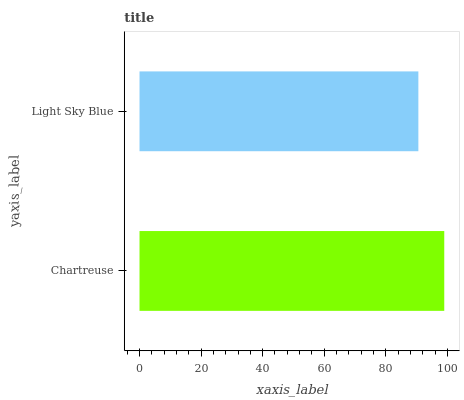Is Light Sky Blue the minimum?
Answer yes or no. Yes. Is Chartreuse the maximum?
Answer yes or no. Yes. Is Light Sky Blue the maximum?
Answer yes or no. No. Is Chartreuse greater than Light Sky Blue?
Answer yes or no. Yes. Is Light Sky Blue less than Chartreuse?
Answer yes or no. Yes. Is Light Sky Blue greater than Chartreuse?
Answer yes or no. No. Is Chartreuse less than Light Sky Blue?
Answer yes or no. No. Is Chartreuse the high median?
Answer yes or no. Yes. Is Light Sky Blue the low median?
Answer yes or no. Yes. Is Light Sky Blue the high median?
Answer yes or no. No. Is Chartreuse the low median?
Answer yes or no. No. 